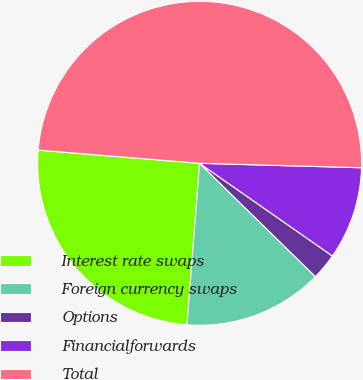<chart> <loc_0><loc_0><loc_500><loc_500><pie_chart><fcel>Interest rate swaps<fcel>Foreign currency swaps<fcel>Options<fcel>Financialforwards<fcel>Total<nl><fcel>25.06%<fcel>13.91%<fcel>2.63%<fcel>9.26%<fcel>49.13%<nl></chart> 